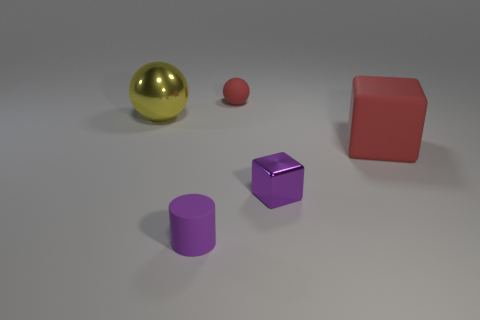There is a large thing that is behind the large block; what is its material?
Ensure brevity in your answer.  Metal. How many other objects are there of the same shape as the yellow object?
Your answer should be very brief. 1. Do the small shiny thing and the big shiny thing have the same shape?
Give a very brief answer. No. There is a purple metal block; are there any small red things behind it?
Provide a short and direct response. Yes. How many objects are either big yellow things or purple metal blocks?
Offer a very short reply. 2. What number of other objects are there of the same size as the purple rubber object?
Keep it short and to the point. 2. How many objects are both behind the purple block and to the right of the big metallic ball?
Your answer should be very brief. 2. Does the red matte object that is behind the large red thing have the same size as the metallic thing on the right side of the large yellow metal ball?
Your answer should be compact. Yes. What size is the shiny object that is behind the matte block?
Offer a very short reply. Large. How many objects are red rubber things behind the yellow ball or big objects that are to the left of the red rubber sphere?
Your answer should be compact. 2. 